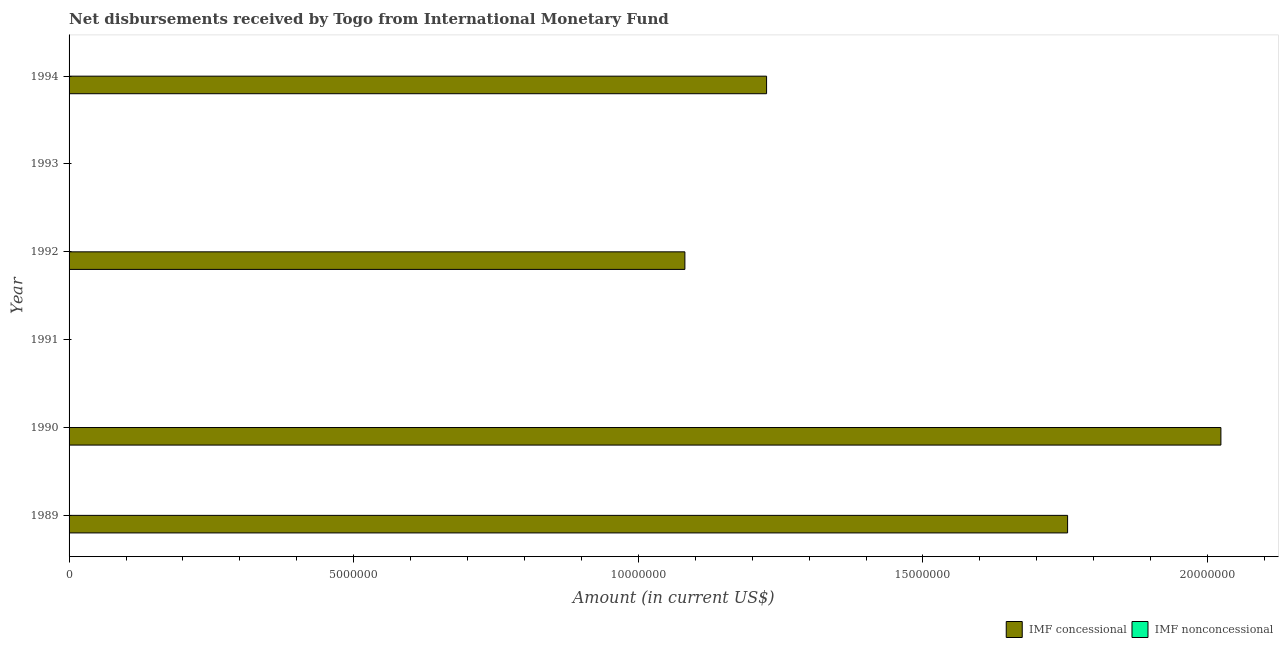What is the label of the 3rd group of bars from the top?
Your answer should be compact. 1992. In how many cases, is the number of bars for a given year not equal to the number of legend labels?
Your answer should be very brief. 6. Across all years, what is the maximum net concessional disbursements from imf?
Your response must be concise. 2.02e+07. Across all years, what is the minimum net concessional disbursements from imf?
Make the answer very short. 0. In which year was the net concessional disbursements from imf maximum?
Ensure brevity in your answer.  1990. What is the total net non concessional disbursements from imf in the graph?
Keep it short and to the point. 0. What is the difference between the net concessional disbursements from imf in 1989 and that in 1992?
Provide a short and direct response. 6.72e+06. What is the difference between the net non concessional disbursements from imf in 1992 and the net concessional disbursements from imf in 1990?
Ensure brevity in your answer.  -2.02e+07. What is the average net concessional disbursements from imf per year?
Provide a succinct answer. 1.01e+07. Is the net concessional disbursements from imf in 1989 less than that in 1994?
Offer a terse response. No. What is the difference between the highest and the second highest net concessional disbursements from imf?
Your answer should be very brief. 2.69e+06. What is the difference between the highest and the lowest net concessional disbursements from imf?
Your answer should be compact. 2.02e+07. In how many years, is the net concessional disbursements from imf greater than the average net concessional disbursements from imf taken over all years?
Keep it short and to the point. 4. How many bars are there?
Your answer should be compact. 4. Are all the bars in the graph horizontal?
Provide a short and direct response. Yes. How many years are there in the graph?
Provide a succinct answer. 6. What is the difference between two consecutive major ticks on the X-axis?
Offer a terse response. 5.00e+06. Does the graph contain grids?
Offer a very short reply. No. Where does the legend appear in the graph?
Your answer should be very brief. Bottom right. How many legend labels are there?
Your answer should be very brief. 2. What is the title of the graph?
Your answer should be very brief. Net disbursements received by Togo from International Monetary Fund. What is the label or title of the Y-axis?
Your response must be concise. Year. What is the Amount (in current US$) of IMF concessional in 1989?
Provide a succinct answer. 1.75e+07. What is the Amount (in current US$) in IMF nonconcessional in 1989?
Your response must be concise. 0. What is the Amount (in current US$) of IMF concessional in 1990?
Offer a very short reply. 2.02e+07. What is the Amount (in current US$) in IMF concessional in 1992?
Keep it short and to the point. 1.08e+07. What is the Amount (in current US$) in IMF nonconcessional in 1992?
Keep it short and to the point. 0. What is the Amount (in current US$) in IMF concessional in 1993?
Make the answer very short. 0. What is the Amount (in current US$) of IMF concessional in 1994?
Make the answer very short. 1.23e+07. What is the Amount (in current US$) of IMF nonconcessional in 1994?
Your response must be concise. 0. Across all years, what is the maximum Amount (in current US$) in IMF concessional?
Your answer should be very brief. 2.02e+07. Across all years, what is the minimum Amount (in current US$) of IMF concessional?
Offer a very short reply. 0. What is the total Amount (in current US$) of IMF concessional in the graph?
Offer a very short reply. 6.08e+07. What is the difference between the Amount (in current US$) in IMF concessional in 1989 and that in 1990?
Give a very brief answer. -2.69e+06. What is the difference between the Amount (in current US$) in IMF concessional in 1989 and that in 1992?
Provide a short and direct response. 6.72e+06. What is the difference between the Amount (in current US$) in IMF concessional in 1989 and that in 1994?
Offer a terse response. 5.29e+06. What is the difference between the Amount (in current US$) in IMF concessional in 1990 and that in 1992?
Make the answer very short. 9.42e+06. What is the difference between the Amount (in current US$) in IMF concessional in 1990 and that in 1994?
Ensure brevity in your answer.  7.98e+06. What is the difference between the Amount (in current US$) of IMF concessional in 1992 and that in 1994?
Keep it short and to the point. -1.44e+06. What is the average Amount (in current US$) in IMF concessional per year?
Give a very brief answer. 1.01e+07. What is the average Amount (in current US$) of IMF nonconcessional per year?
Give a very brief answer. 0. What is the ratio of the Amount (in current US$) of IMF concessional in 1989 to that in 1990?
Your answer should be compact. 0.87. What is the ratio of the Amount (in current US$) in IMF concessional in 1989 to that in 1992?
Make the answer very short. 1.62. What is the ratio of the Amount (in current US$) in IMF concessional in 1989 to that in 1994?
Your answer should be very brief. 1.43. What is the ratio of the Amount (in current US$) in IMF concessional in 1990 to that in 1992?
Ensure brevity in your answer.  1.87. What is the ratio of the Amount (in current US$) in IMF concessional in 1990 to that in 1994?
Provide a succinct answer. 1.65. What is the ratio of the Amount (in current US$) of IMF concessional in 1992 to that in 1994?
Your answer should be very brief. 0.88. What is the difference between the highest and the second highest Amount (in current US$) of IMF concessional?
Give a very brief answer. 2.69e+06. What is the difference between the highest and the lowest Amount (in current US$) in IMF concessional?
Your answer should be compact. 2.02e+07. 